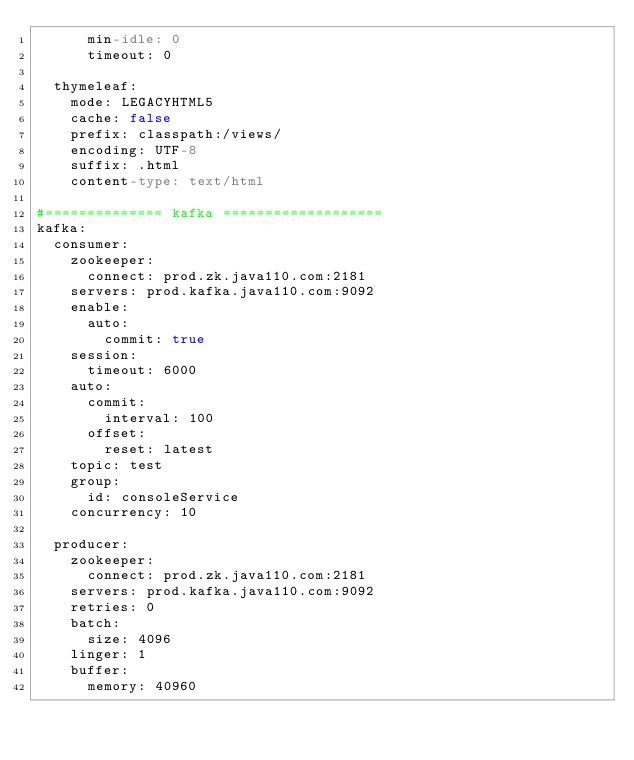<code> <loc_0><loc_0><loc_500><loc_500><_YAML_>      min-idle: 0
      timeout: 0

  thymeleaf:
    mode: LEGACYHTML5
    cache: false
    prefix: classpath:/views/
    encoding: UTF-8
    suffix: .html
    content-type: text/html

#============== kafka ===================
kafka:
  consumer:
    zookeeper:
      connect: prod.zk.java110.com:2181
    servers: prod.kafka.java110.com:9092
    enable:
      auto:
        commit: true
    session:
      timeout: 6000
    auto:
      commit:
        interval: 100
      offset:
        reset: latest
    topic: test
    group:
      id: consoleService
    concurrency: 10

  producer:
    zookeeper:
      connect: prod.zk.java110.com:2181
    servers: prod.kafka.java110.com:9092
    retries: 0
    batch:
      size: 4096
    linger: 1
    buffer:
      memory: 40960


</code> 